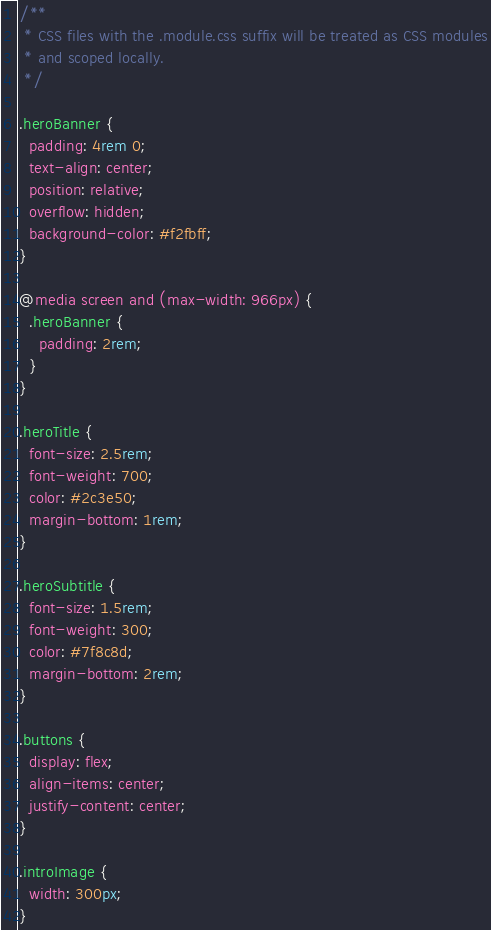Convert code to text. <code><loc_0><loc_0><loc_500><loc_500><_CSS_>/**
 * CSS files with the .module.css suffix will be treated as CSS modules
 * and scoped locally.
 */

.heroBanner {
  padding: 4rem 0;
  text-align: center;
  position: relative;
  overflow: hidden;
  background-color: #f2fbff;
}

@media screen and (max-width: 966px) {
  .heroBanner {
    padding: 2rem;
  }
}

.heroTitle {
  font-size: 2.5rem;
  font-weight: 700;
  color: #2c3e50;
  margin-bottom: 1rem;
}

.heroSubtitle {
  font-size: 1.5rem;
  font-weight: 300;
  color: #7f8c8d;
  margin-bottom: 2rem;
}

.buttons {
  display: flex;
  align-items: center;
  justify-content: center;
}

.introImage {
  width: 300px;
}</code> 